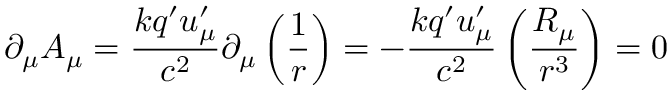<formula> <loc_0><loc_0><loc_500><loc_500>\partial _ { \mu } A _ { \mu } = \frac { k q ^ { \prime } u _ { \mu } ^ { \prime } } { c ^ { 2 } } \partial _ { \mu } \left ( \frac { 1 } { r } \right ) = - \frac { k q ^ { \prime } u _ { \mu } ^ { \prime } } { c ^ { 2 } } \left ( \frac { R _ { \mu } } { r ^ { 3 } } \right ) = 0</formula> 